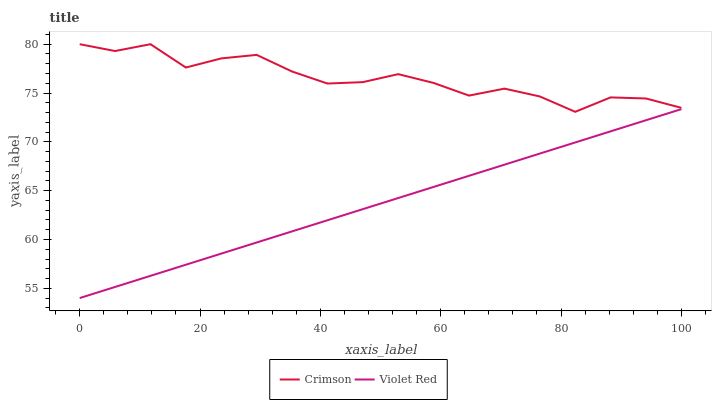Does Violet Red have the minimum area under the curve?
Answer yes or no. Yes. Does Crimson have the maximum area under the curve?
Answer yes or no. Yes. Does Violet Red have the maximum area under the curve?
Answer yes or no. No. Is Violet Red the smoothest?
Answer yes or no. Yes. Is Crimson the roughest?
Answer yes or no. Yes. Is Violet Red the roughest?
Answer yes or no. No. Does Crimson have the highest value?
Answer yes or no. Yes. Does Violet Red have the highest value?
Answer yes or no. No. Is Violet Red less than Crimson?
Answer yes or no. Yes. Is Crimson greater than Violet Red?
Answer yes or no. Yes. Does Violet Red intersect Crimson?
Answer yes or no. No. 